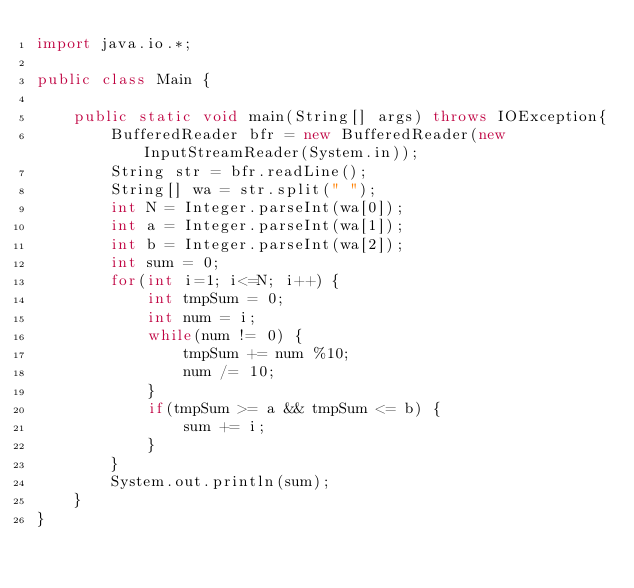Convert code to text. <code><loc_0><loc_0><loc_500><loc_500><_Java_>import java.io.*;

public class Main {

	public static void main(String[] args) throws IOException{
		BufferedReader bfr = new BufferedReader(new InputStreamReader(System.in));
		String str = bfr.readLine();
		String[] wa = str.split(" ");
		int N = Integer.parseInt(wa[0]);
		int a = Integer.parseInt(wa[1]);
		int b = Integer.parseInt(wa[2]);
		int sum = 0;
		for(int i=1; i<=N; i++) {
			int tmpSum = 0;
			int num = i;
			while(num != 0) {
				tmpSum += num %10;
				num /= 10;
			}
			if(tmpSum >= a && tmpSum <= b) {
				sum += i;
			}
		}
		System.out.println(sum);
	}
}</code> 